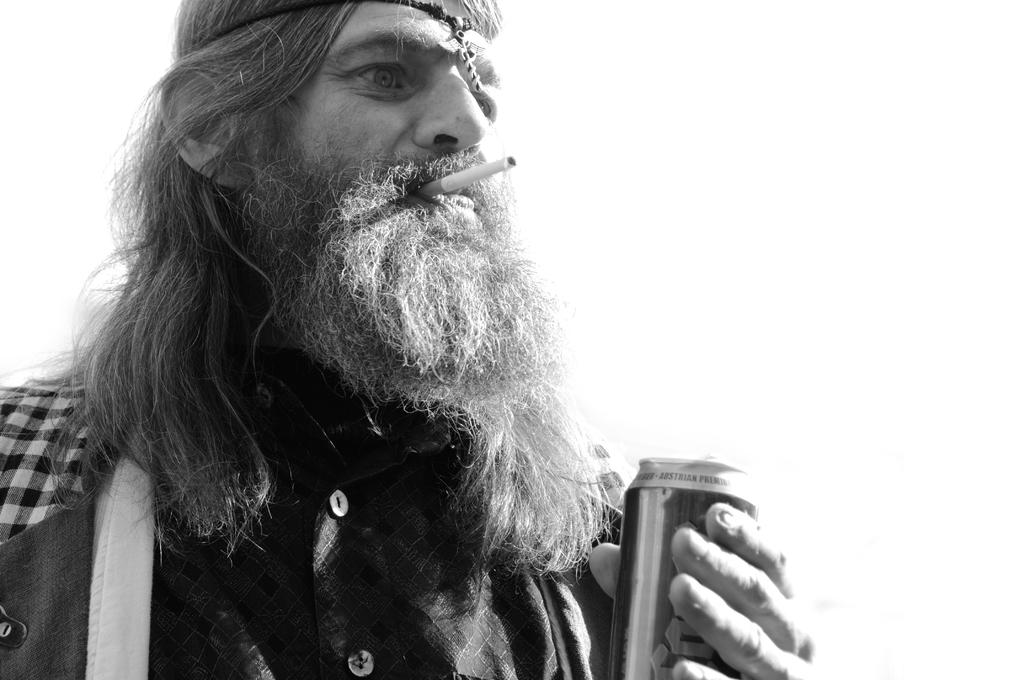What is the main subject of the image? There is a person standing in the image. What is the person holding in the image? The person is holding a juice can. What else can be seen in the person's mouth in the image? The person has a cigarette in his mouth. Where are the fairies resting in the image? There are no fairies present in the image. What action is the person taking with the juice can in the image? The image does not show the person taking any action with the juice can, only holding it. 